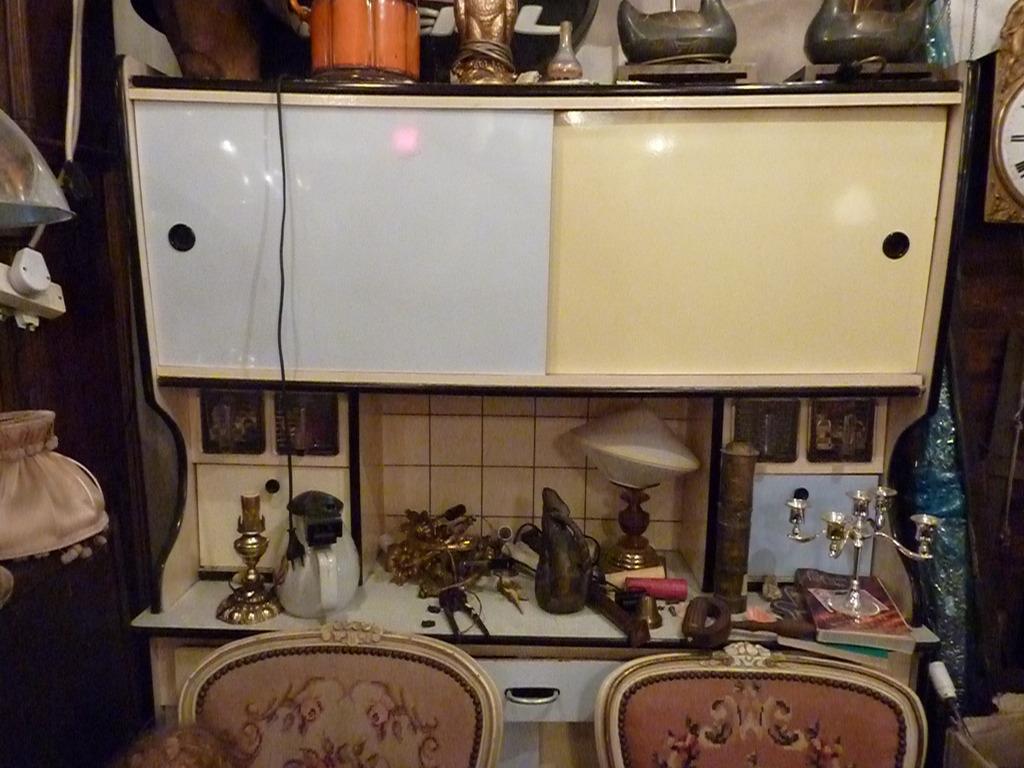Please provide a concise description of this image. In the image there is a cabinet and on the cabinet there are different objects, on the left side there is a plug in the switchboard and on the right side there is a clock. 